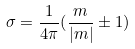<formula> <loc_0><loc_0><loc_500><loc_500>\sigma = \frac { 1 } { 4 \pi } ( \frac { m } { | m | } \pm 1 )</formula> 